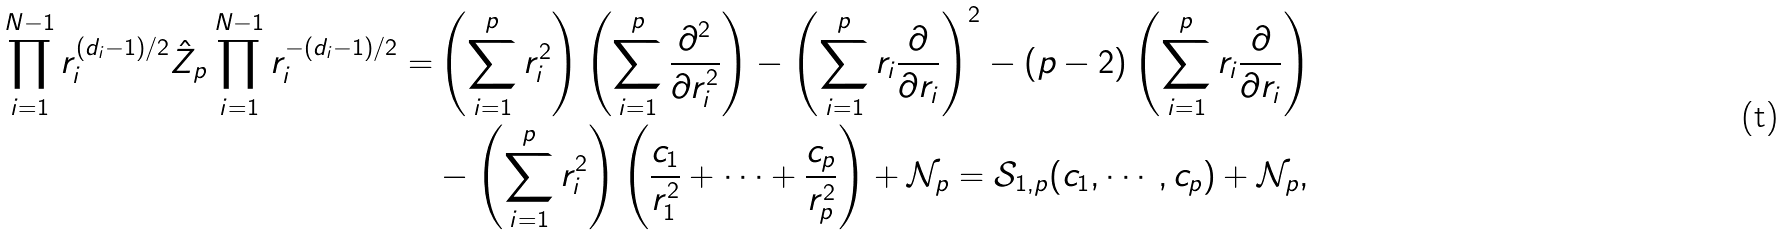Convert formula to latex. <formula><loc_0><loc_0><loc_500><loc_500>\prod _ { i = 1 } ^ { N - 1 } r _ { i } ^ { ( d _ { i } - 1 ) / 2 } \hat { Z } _ { p } \prod _ { i = 1 } ^ { N - 1 } r _ { i } ^ { - ( d _ { i } - 1 ) / 2 } = & \left ( \sum _ { i = 1 } ^ { p } r _ { i } ^ { 2 } \right ) \left ( \sum _ { i = 1 } ^ { p } \frac { \partial ^ { 2 } } { \partial r _ { i } ^ { 2 } } \right ) - \left ( \sum _ { i = 1 } ^ { p } r _ { i } \frac { \partial } { \partial r _ { i } } \right ) ^ { 2 } - ( p - 2 ) \left ( \sum _ { i = 1 } ^ { p } r _ { i } \frac { \partial } { \partial r _ { i } } \right ) \\ & - \left ( \sum _ { i = 1 } ^ { p } r _ { i } ^ { 2 } \right ) \left ( \frac { c _ { 1 } } { r _ { 1 } ^ { 2 } } + \cdots + \frac { c _ { p } } { r _ { p } ^ { 2 } } \right ) + \mathcal { N } _ { p } = \mathcal { S } _ { 1 , p } ( c _ { 1 } , \cdots , c _ { p } ) + \mathcal { N } _ { p } ,</formula> 